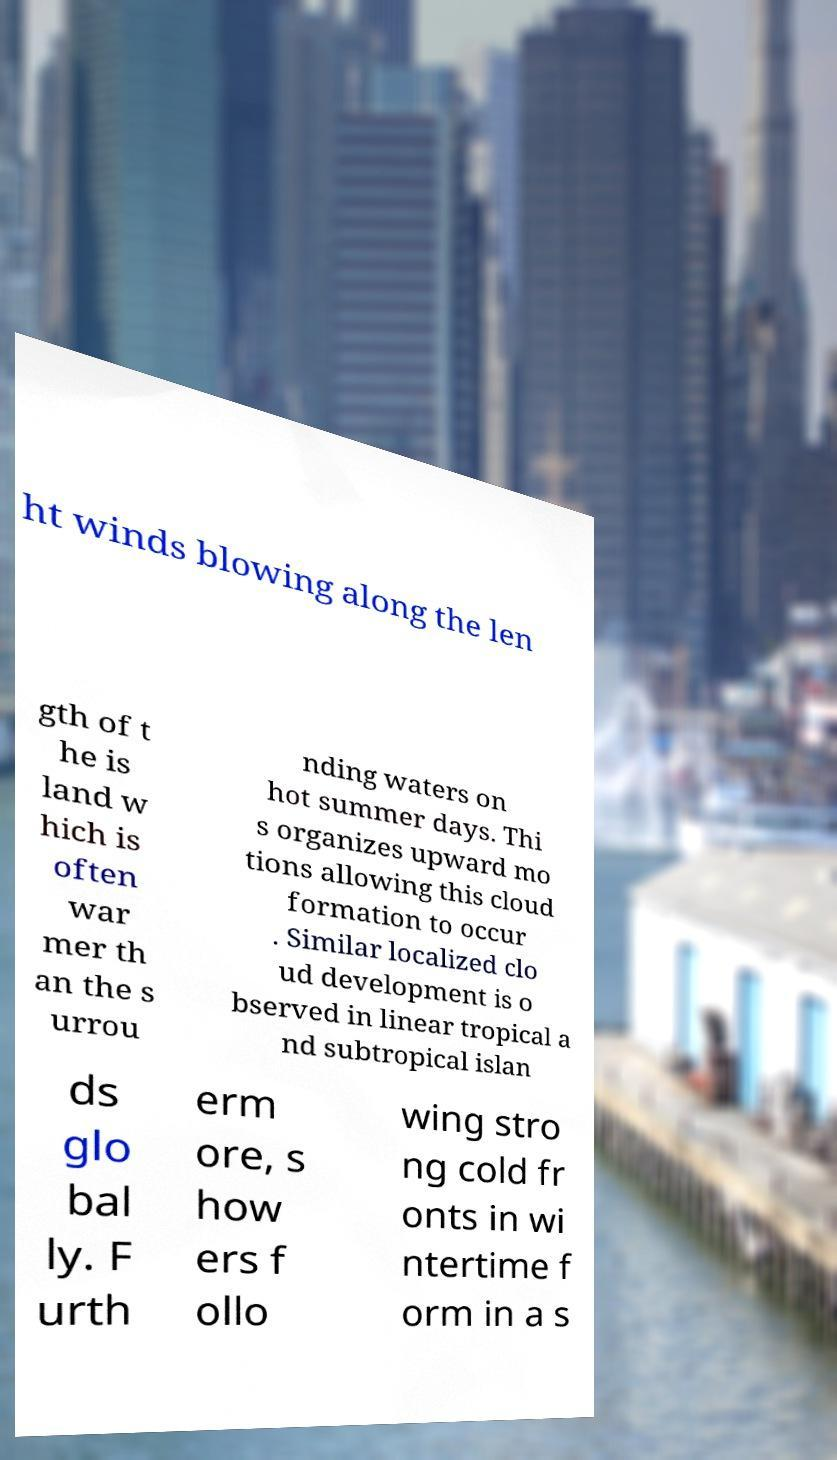For documentation purposes, I need the text within this image transcribed. Could you provide that? ht winds blowing along the len gth of t he is land w hich is often war mer th an the s urrou nding waters on hot summer days. Thi s organizes upward mo tions allowing this cloud formation to occur . Similar localized clo ud development is o bserved in linear tropical a nd subtropical islan ds glo bal ly. F urth erm ore, s how ers f ollo wing stro ng cold fr onts in wi ntertime f orm in a s 